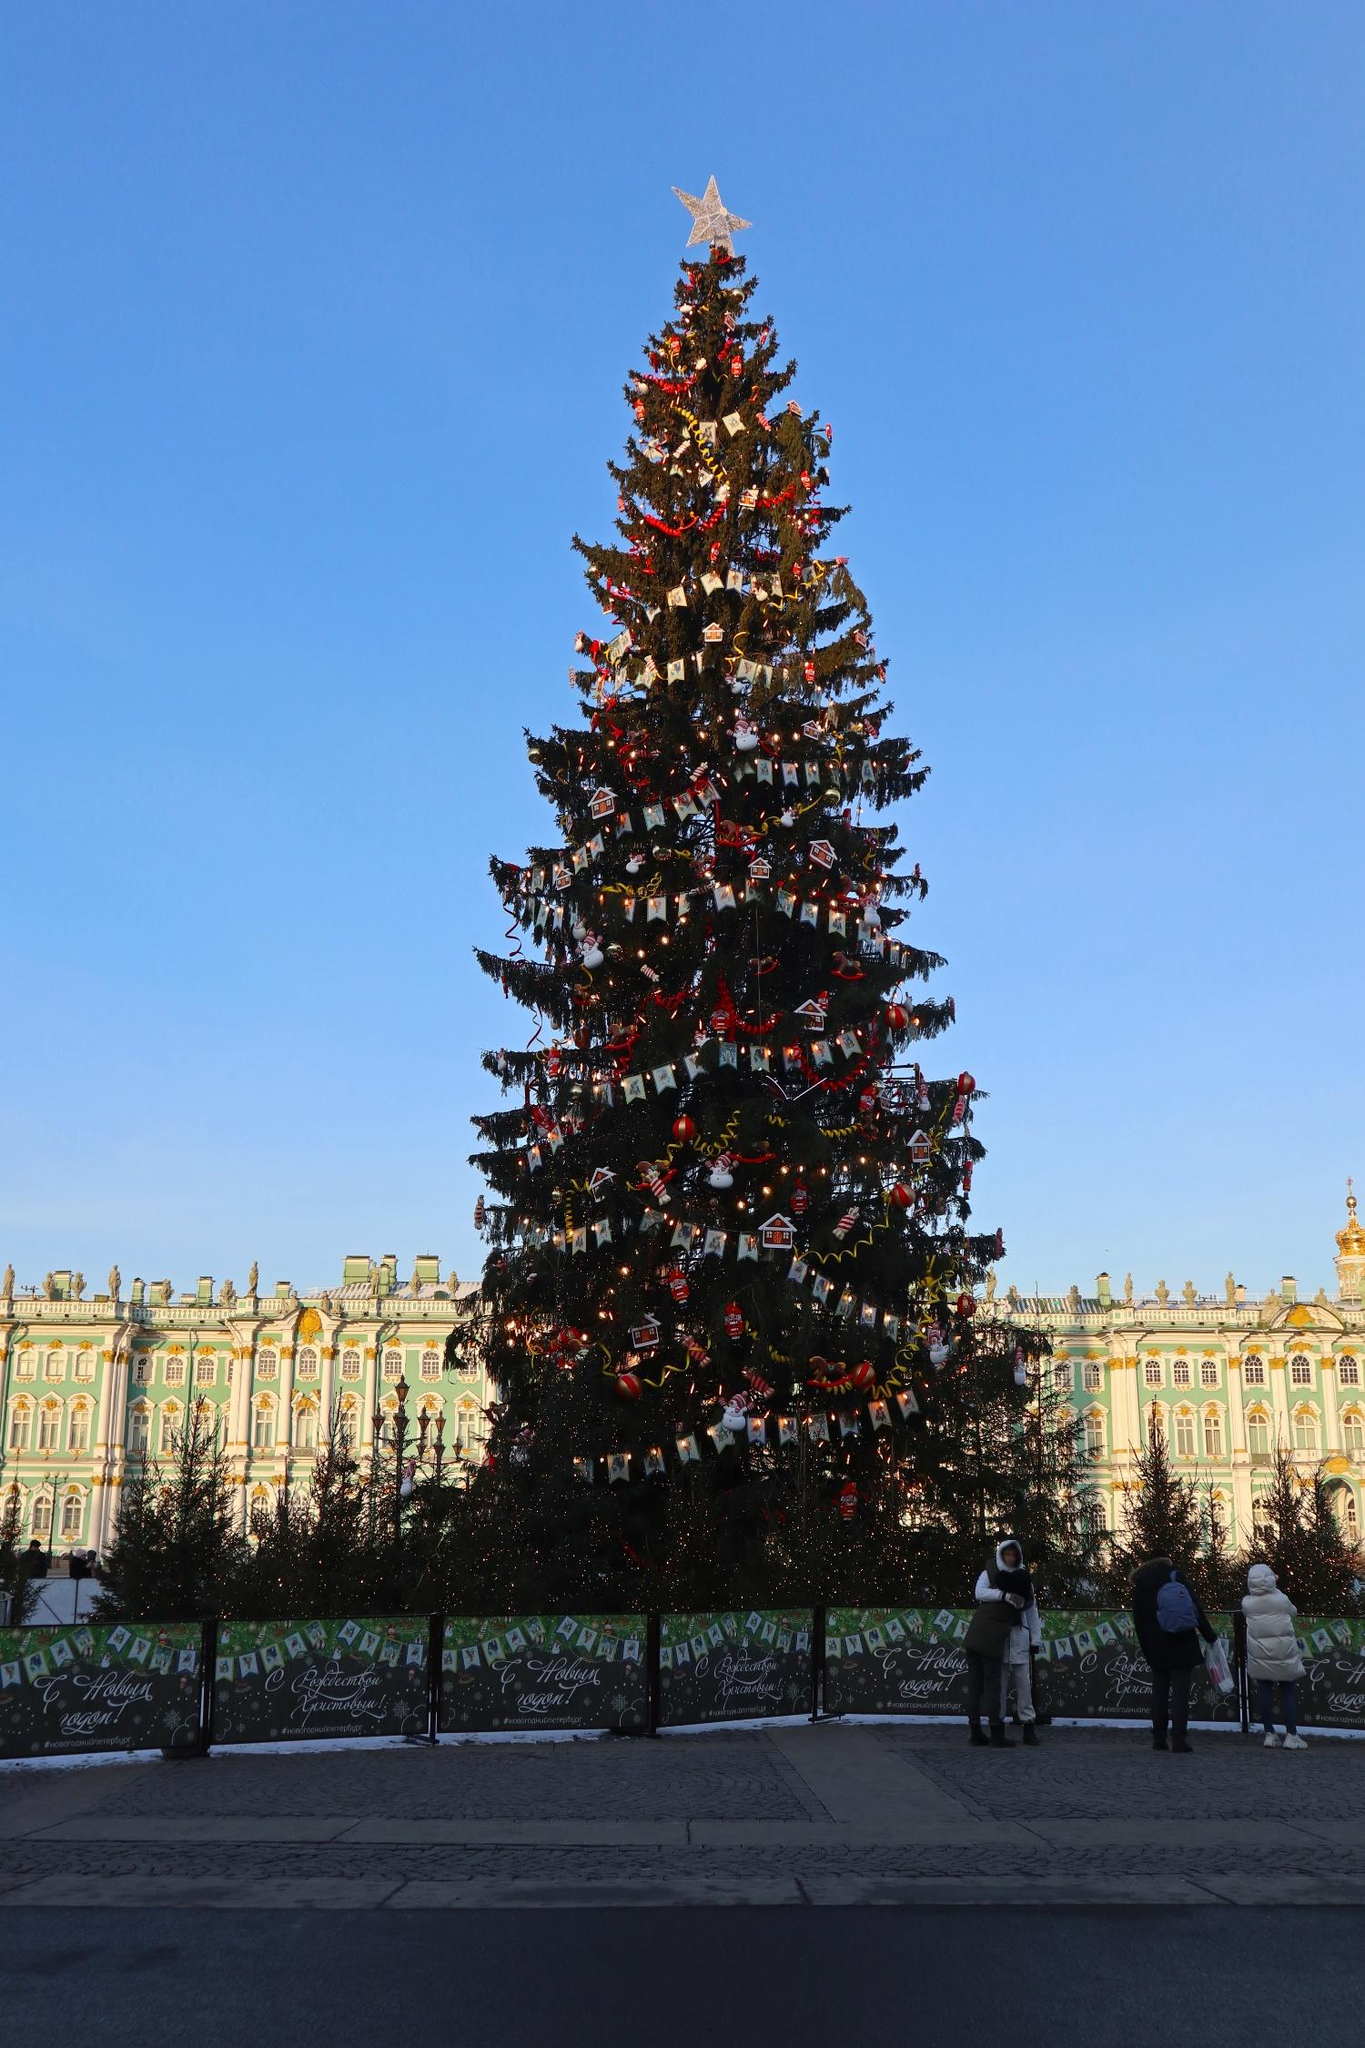If this tree could talk, what stories would it share? If this tree could talk, it would share countless stories of the joy and wonder it has seen over the years. It would tell tales of children’s eyes lighting up with excitement when they see it for the first time, of couples sharing moments of love and togetherness, and of friends and families gathering to celebrate. It would recount the effort and care taken by those who decorate it, ensuring it shines brightly each year. The tree would also speak of the historical significance of the building behind it, adding a layer of cultural heritage to its festive stories. Through its tales, the tree would embody the timeless spirit of Christmas, weaving together memories of happiness, love, and unity. What other decorations would you add to this tree to enhance its charm? To enhance the charm of this already beautiful tree, I would consider adding strings of popcorn and cranberries for a traditional touch. Hand-made ornaments showcasing cultural elements from around the world could also bring a sense of global unity and diversity. Fairy lights that change color could add a dynamic and enchanting effect. A few delicate icicles and snowflake ornaments would evoke a winter wonderland feel. Additionally, incorporating some natural elements like pinecones and dried oranges could add a cozy, rustic charm to this magnificent festive display. 